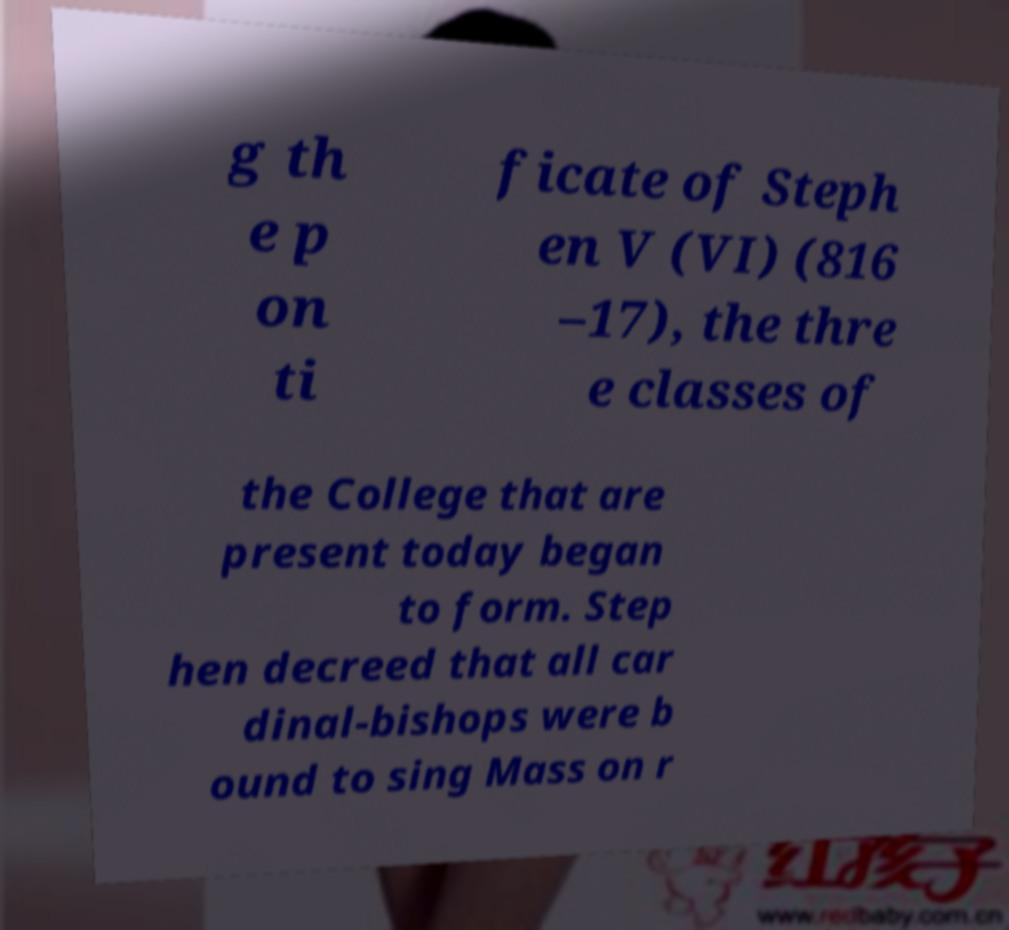Can you accurately transcribe the text from the provided image for me? g th e p on ti ficate of Steph en V (VI) (816 –17), the thre e classes of the College that are present today began to form. Step hen decreed that all car dinal-bishops were b ound to sing Mass on r 